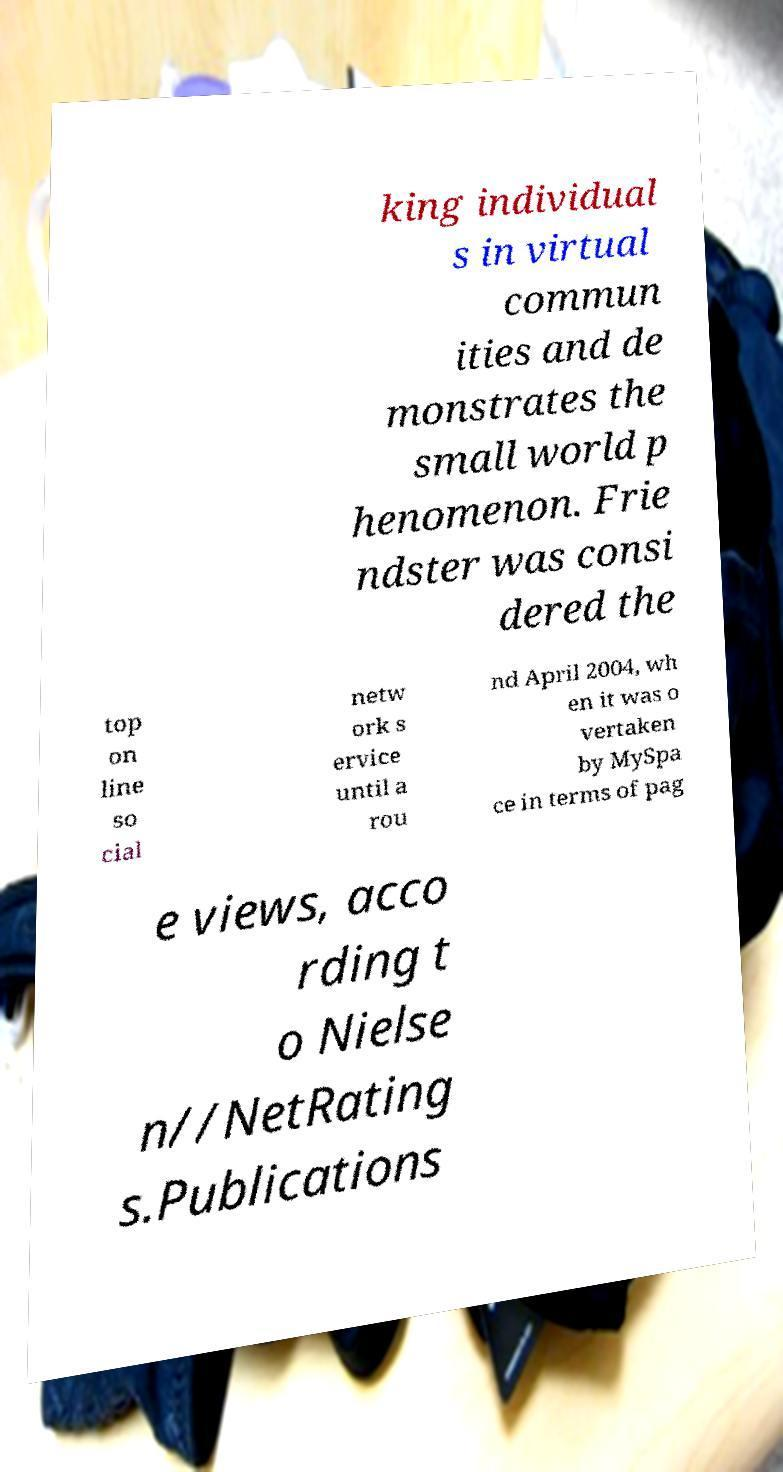Can you read and provide the text displayed in the image?This photo seems to have some interesting text. Can you extract and type it out for me? king individual s in virtual commun ities and de monstrates the small world p henomenon. Frie ndster was consi dered the top on line so cial netw ork s ervice until a rou nd April 2004, wh en it was o vertaken by MySpa ce in terms of pag e views, acco rding t o Nielse n//NetRating s.Publications 